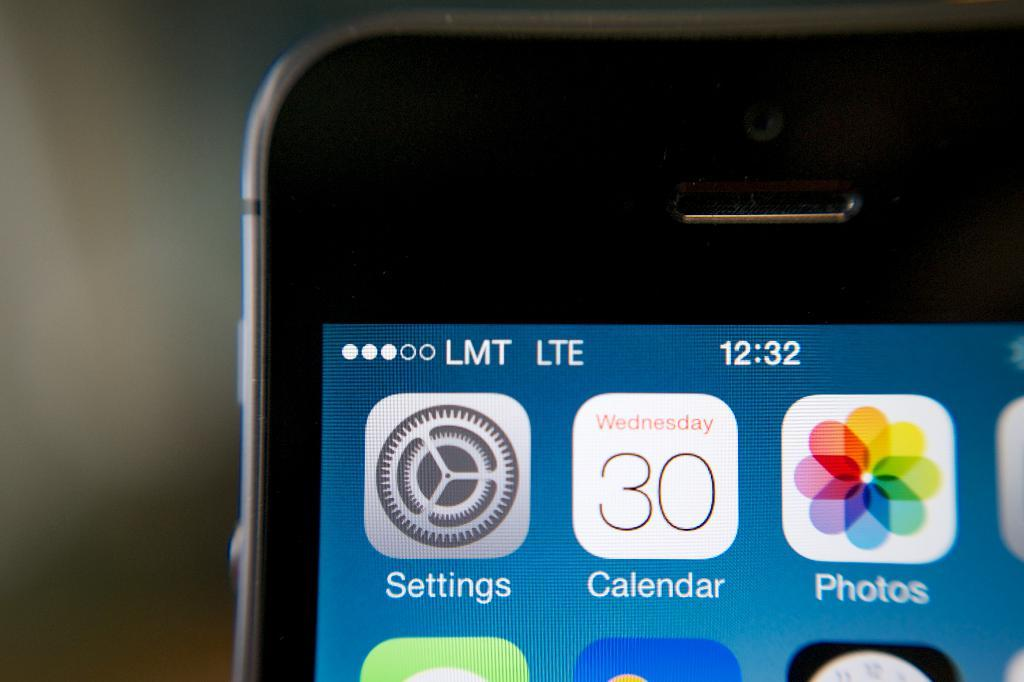What type of device is visible in the image? There is an iPhone in the image. Can you describe the background of the image? The background of the image is blurred. What type of wheel is visible in the image? There is no wheel present in the image; it features an iPhone and a blurred background. 